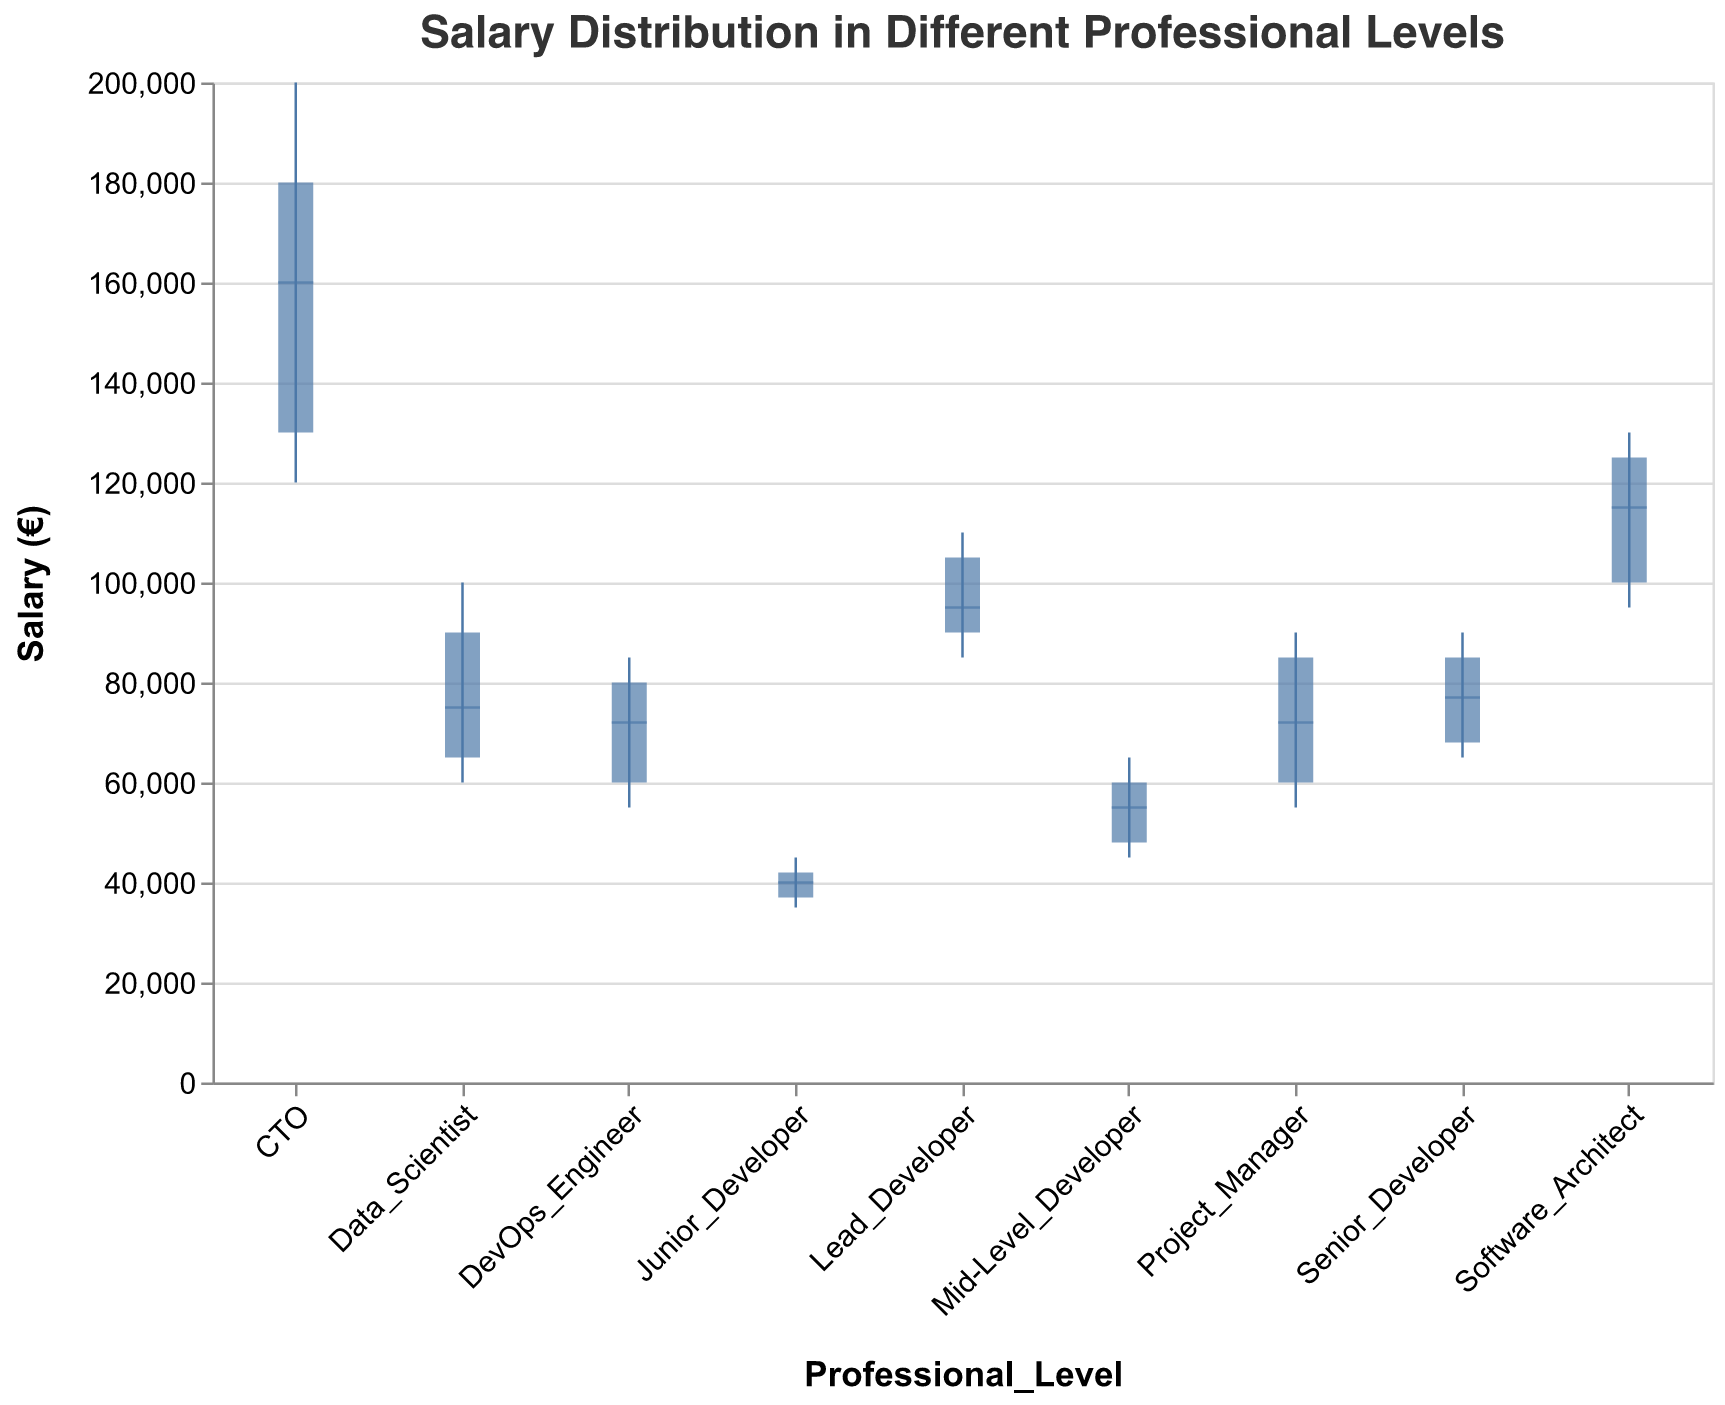What's the title of the figure? The main text at the top of the figure typically contains the title.
Answer: Salary Distribution in Different Professional Levels What is the minimum salary for a Junior Developer? To find the minimum salary for a Junior Developer, refer to the lowest point of the vertical line for the Junior Developer category.
Answer: 35,000 Which professional level shows the highest median salary? The median salary is marked by the central tick for each category. Identify the highest tick mark location to find the answer.
Answer: CTO What is the salary range for a Mid-Level Developer? The salary range is indicated by the endpoints of the vertical lines. Check the minimum and maximum values for the Mid-Level Developer category.
Answer: 45,000 - 65,000 How does the 3rd quartile salary of a DevOps Engineer compare to that of a Data Scientist? Look for the upper limit of the bar (not the vertical line) for both categories and compare their positions.
Answer: The 3rd quartile salary of a Data Scientist (90,000) is higher than that of a DevOps Engineer (80,000) Which professional level has the smallest interquartile range (IQR)? The IQR is represented by the length of the bar (from 1st to 3rd quartile). Compare the lengths of these bars for all categories.
Answer: Junior Developer Calculate the median salary difference between a Senior Developer and a Project Manager. Find the median salaries for both Senior Developer and Project Manager by locating the central tick mark in each bar and then subtract the two values.
Answer: 77,000 - 72,000 = 5,000 What is the 1st quartile salary for a Lead Developer? Refer to the lower limit of the bar for the Lead Developer category to find the 1st quartile salary.
Answer: 90,000 Which professional level has the widest range between the minimum and maximum salaries? The range is indicated by the length of the vertical line. Compare the lengths of these lines for all categories.
Answer: CTO How does the median salary of a Software Architect compare to that of a Lead Developer? Find the black line (tick) within the bars of both categories and compare their vertical positions.
Answer: The median salary of a Software Architect (115,000) is higher than that of a Lead Developer (95,000) 